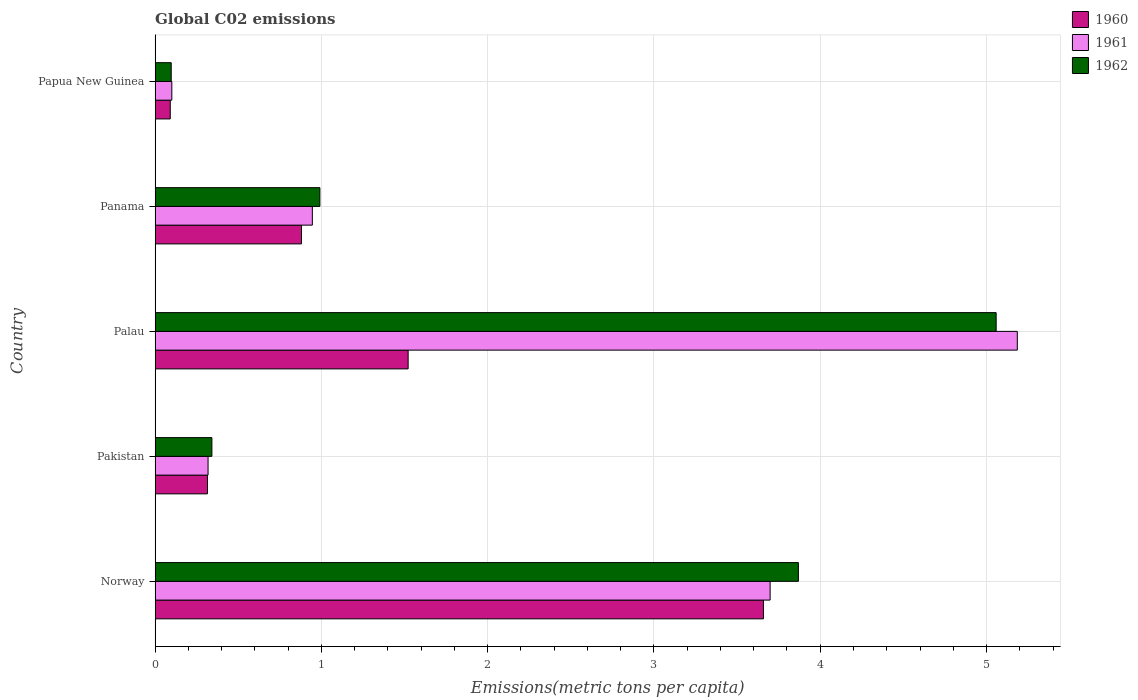How many different coloured bars are there?
Your answer should be compact. 3. Are the number of bars per tick equal to the number of legend labels?
Your response must be concise. Yes. Are the number of bars on each tick of the Y-axis equal?
Your response must be concise. Yes. What is the amount of CO2 emitted in in 1962 in Pakistan?
Offer a very short reply. 0.34. Across all countries, what is the maximum amount of CO2 emitted in in 1960?
Provide a short and direct response. 3.66. Across all countries, what is the minimum amount of CO2 emitted in in 1961?
Your answer should be very brief. 0.1. In which country was the amount of CO2 emitted in in 1960 maximum?
Provide a succinct answer. Norway. In which country was the amount of CO2 emitted in in 1961 minimum?
Offer a very short reply. Papua New Guinea. What is the total amount of CO2 emitted in in 1961 in the graph?
Your answer should be very brief. 10.25. What is the difference between the amount of CO2 emitted in in 1960 in Norway and that in Papua New Guinea?
Offer a terse response. 3.57. What is the difference between the amount of CO2 emitted in in 1962 in Panama and the amount of CO2 emitted in in 1960 in Papua New Guinea?
Your answer should be compact. 0.9. What is the average amount of CO2 emitted in in 1962 per country?
Keep it short and to the point. 2.07. What is the difference between the amount of CO2 emitted in in 1960 and amount of CO2 emitted in in 1962 in Norway?
Keep it short and to the point. -0.21. What is the ratio of the amount of CO2 emitted in in 1961 in Norway to that in Papua New Guinea?
Offer a very short reply. 36.7. Is the difference between the amount of CO2 emitted in in 1960 in Norway and Panama greater than the difference between the amount of CO2 emitted in in 1962 in Norway and Panama?
Make the answer very short. No. What is the difference between the highest and the second highest amount of CO2 emitted in in 1961?
Make the answer very short. 1.49. What is the difference between the highest and the lowest amount of CO2 emitted in in 1961?
Your answer should be compact. 5.08. What does the 1st bar from the top in Pakistan represents?
Provide a short and direct response. 1962. What does the 1st bar from the bottom in Norway represents?
Your answer should be very brief. 1960. What is the difference between two consecutive major ticks on the X-axis?
Provide a short and direct response. 1. Are the values on the major ticks of X-axis written in scientific E-notation?
Provide a short and direct response. No. Does the graph contain grids?
Provide a succinct answer. Yes. Where does the legend appear in the graph?
Your answer should be compact. Top right. How many legend labels are there?
Offer a very short reply. 3. What is the title of the graph?
Give a very brief answer. Global C02 emissions. What is the label or title of the X-axis?
Make the answer very short. Emissions(metric tons per capita). What is the Emissions(metric tons per capita) of 1960 in Norway?
Provide a succinct answer. 3.66. What is the Emissions(metric tons per capita) of 1961 in Norway?
Provide a short and direct response. 3.7. What is the Emissions(metric tons per capita) of 1962 in Norway?
Offer a terse response. 3.87. What is the Emissions(metric tons per capita) of 1960 in Pakistan?
Your response must be concise. 0.32. What is the Emissions(metric tons per capita) of 1961 in Pakistan?
Keep it short and to the point. 0.32. What is the Emissions(metric tons per capita) of 1962 in Pakistan?
Offer a terse response. 0.34. What is the Emissions(metric tons per capita) in 1960 in Palau?
Give a very brief answer. 1.52. What is the Emissions(metric tons per capita) of 1961 in Palau?
Your answer should be compact. 5.19. What is the Emissions(metric tons per capita) in 1962 in Palau?
Your answer should be very brief. 5.06. What is the Emissions(metric tons per capita) in 1960 in Panama?
Provide a succinct answer. 0.88. What is the Emissions(metric tons per capita) in 1961 in Panama?
Make the answer very short. 0.95. What is the Emissions(metric tons per capita) of 1962 in Panama?
Make the answer very short. 0.99. What is the Emissions(metric tons per capita) in 1960 in Papua New Guinea?
Make the answer very short. 0.09. What is the Emissions(metric tons per capita) of 1961 in Papua New Guinea?
Keep it short and to the point. 0.1. What is the Emissions(metric tons per capita) of 1962 in Papua New Guinea?
Keep it short and to the point. 0.1. Across all countries, what is the maximum Emissions(metric tons per capita) of 1960?
Offer a terse response. 3.66. Across all countries, what is the maximum Emissions(metric tons per capita) of 1961?
Your answer should be compact. 5.19. Across all countries, what is the maximum Emissions(metric tons per capita) of 1962?
Provide a short and direct response. 5.06. Across all countries, what is the minimum Emissions(metric tons per capita) of 1960?
Your answer should be compact. 0.09. Across all countries, what is the minimum Emissions(metric tons per capita) in 1961?
Your answer should be very brief. 0.1. Across all countries, what is the minimum Emissions(metric tons per capita) in 1962?
Offer a very short reply. 0.1. What is the total Emissions(metric tons per capita) of 1960 in the graph?
Give a very brief answer. 6.47. What is the total Emissions(metric tons per capita) in 1961 in the graph?
Offer a terse response. 10.25. What is the total Emissions(metric tons per capita) in 1962 in the graph?
Provide a succinct answer. 10.36. What is the difference between the Emissions(metric tons per capita) of 1960 in Norway and that in Pakistan?
Make the answer very short. 3.34. What is the difference between the Emissions(metric tons per capita) of 1961 in Norway and that in Pakistan?
Your response must be concise. 3.38. What is the difference between the Emissions(metric tons per capita) in 1962 in Norway and that in Pakistan?
Give a very brief answer. 3.53. What is the difference between the Emissions(metric tons per capita) of 1960 in Norway and that in Palau?
Offer a very short reply. 2.14. What is the difference between the Emissions(metric tons per capita) of 1961 in Norway and that in Palau?
Ensure brevity in your answer.  -1.49. What is the difference between the Emissions(metric tons per capita) in 1962 in Norway and that in Palau?
Provide a short and direct response. -1.19. What is the difference between the Emissions(metric tons per capita) in 1960 in Norway and that in Panama?
Your response must be concise. 2.78. What is the difference between the Emissions(metric tons per capita) in 1961 in Norway and that in Panama?
Ensure brevity in your answer.  2.75. What is the difference between the Emissions(metric tons per capita) in 1962 in Norway and that in Panama?
Your response must be concise. 2.88. What is the difference between the Emissions(metric tons per capita) of 1960 in Norway and that in Papua New Guinea?
Offer a terse response. 3.57. What is the difference between the Emissions(metric tons per capita) in 1961 in Norway and that in Papua New Guinea?
Provide a short and direct response. 3.6. What is the difference between the Emissions(metric tons per capita) in 1962 in Norway and that in Papua New Guinea?
Your answer should be compact. 3.77. What is the difference between the Emissions(metric tons per capita) of 1960 in Pakistan and that in Palau?
Offer a terse response. -1.21. What is the difference between the Emissions(metric tons per capita) of 1961 in Pakistan and that in Palau?
Your answer should be very brief. -4.87. What is the difference between the Emissions(metric tons per capita) in 1962 in Pakistan and that in Palau?
Provide a succinct answer. -4.72. What is the difference between the Emissions(metric tons per capita) in 1960 in Pakistan and that in Panama?
Ensure brevity in your answer.  -0.57. What is the difference between the Emissions(metric tons per capita) of 1961 in Pakistan and that in Panama?
Give a very brief answer. -0.63. What is the difference between the Emissions(metric tons per capita) in 1962 in Pakistan and that in Panama?
Ensure brevity in your answer.  -0.65. What is the difference between the Emissions(metric tons per capita) of 1960 in Pakistan and that in Papua New Guinea?
Your answer should be very brief. 0.22. What is the difference between the Emissions(metric tons per capita) of 1961 in Pakistan and that in Papua New Guinea?
Give a very brief answer. 0.22. What is the difference between the Emissions(metric tons per capita) of 1962 in Pakistan and that in Papua New Guinea?
Your response must be concise. 0.24. What is the difference between the Emissions(metric tons per capita) in 1960 in Palau and that in Panama?
Make the answer very short. 0.64. What is the difference between the Emissions(metric tons per capita) of 1961 in Palau and that in Panama?
Your answer should be very brief. 4.24. What is the difference between the Emissions(metric tons per capita) in 1962 in Palau and that in Panama?
Offer a very short reply. 4.07. What is the difference between the Emissions(metric tons per capita) of 1960 in Palau and that in Papua New Guinea?
Provide a short and direct response. 1.43. What is the difference between the Emissions(metric tons per capita) in 1961 in Palau and that in Papua New Guinea?
Your answer should be very brief. 5.08. What is the difference between the Emissions(metric tons per capita) in 1962 in Palau and that in Papua New Guinea?
Your answer should be compact. 4.96. What is the difference between the Emissions(metric tons per capita) in 1960 in Panama and that in Papua New Guinea?
Your answer should be very brief. 0.79. What is the difference between the Emissions(metric tons per capita) in 1961 in Panama and that in Papua New Guinea?
Make the answer very short. 0.84. What is the difference between the Emissions(metric tons per capita) of 1962 in Panama and that in Papua New Guinea?
Keep it short and to the point. 0.89. What is the difference between the Emissions(metric tons per capita) of 1960 in Norway and the Emissions(metric tons per capita) of 1961 in Pakistan?
Your answer should be compact. 3.34. What is the difference between the Emissions(metric tons per capita) in 1960 in Norway and the Emissions(metric tons per capita) in 1962 in Pakistan?
Make the answer very short. 3.32. What is the difference between the Emissions(metric tons per capita) of 1961 in Norway and the Emissions(metric tons per capita) of 1962 in Pakistan?
Offer a very short reply. 3.36. What is the difference between the Emissions(metric tons per capita) of 1960 in Norway and the Emissions(metric tons per capita) of 1961 in Palau?
Make the answer very short. -1.53. What is the difference between the Emissions(metric tons per capita) in 1960 in Norway and the Emissions(metric tons per capita) in 1962 in Palau?
Your answer should be compact. -1.4. What is the difference between the Emissions(metric tons per capita) of 1961 in Norway and the Emissions(metric tons per capita) of 1962 in Palau?
Provide a short and direct response. -1.36. What is the difference between the Emissions(metric tons per capita) of 1960 in Norway and the Emissions(metric tons per capita) of 1961 in Panama?
Provide a short and direct response. 2.71. What is the difference between the Emissions(metric tons per capita) of 1960 in Norway and the Emissions(metric tons per capita) of 1962 in Panama?
Offer a terse response. 2.67. What is the difference between the Emissions(metric tons per capita) of 1961 in Norway and the Emissions(metric tons per capita) of 1962 in Panama?
Give a very brief answer. 2.71. What is the difference between the Emissions(metric tons per capita) in 1960 in Norway and the Emissions(metric tons per capita) in 1961 in Papua New Guinea?
Ensure brevity in your answer.  3.56. What is the difference between the Emissions(metric tons per capita) in 1960 in Norway and the Emissions(metric tons per capita) in 1962 in Papua New Guinea?
Your answer should be very brief. 3.56. What is the difference between the Emissions(metric tons per capita) of 1961 in Norway and the Emissions(metric tons per capita) of 1962 in Papua New Guinea?
Ensure brevity in your answer.  3.6. What is the difference between the Emissions(metric tons per capita) in 1960 in Pakistan and the Emissions(metric tons per capita) in 1961 in Palau?
Ensure brevity in your answer.  -4.87. What is the difference between the Emissions(metric tons per capita) of 1960 in Pakistan and the Emissions(metric tons per capita) of 1962 in Palau?
Your answer should be compact. -4.74. What is the difference between the Emissions(metric tons per capita) in 1961 in Pakistan and the Emissions(metric tons per capita) in 1962 in Palau?
Provide a short and direct response. -4.74. What is the difference between the Emissions(metric tons per capita) of 1960 in Pakistan and the Emissions(metric tons per capita) of 1961 in Panama?
Your answer should be compact. -0.63. What is the difference between the Emissions(metric tons per capita) of 1960 in Pakistan and the Emissions(metric tons per capita) of 1962 in Panama?
Your answer should be compact. -0.68. What is the difference between the Emissions(metric tons per capita) in 1961 in Pakistan and the Emissions(metric tons per capita) in 1962 in Panama?
Offer a terse response. -0.67. What is the difference between the Emissions(metric tons per capita) in 1960 in Pakistan and the Emissions(metric tons per capita) in 1961 in Papua New Guinea?
Your answer should be very brief. 0.21. What is the difference between the Emissions(metric tons per capita) in 1960 in Pakistan and the Emissions(metric tons per capita) in 1962 in Papua New Guinea?
Provide a short and direct response. 0.22. What is the difference between the Emissions(metric tons per capita) in 1961 in Pakistan and the Emissions(metric tons per capita) in 1962 in Papua New Guinea?
Ensure brevity in your answer.  0.22. What is the difference between the Emissions(metric tons per capita) of 1960 in Palau and the Emissions(metric tons per capita) of 1961 in Panama?
Your answer should be compact. 0.58. What is the difference between the Emissions(metric tons per capita) in 1960 in Palau and the Emissions(metric tons per capita) in 1962 in Panama?
Your answer should be compact. 0.53. What is the difference between the Emissions(metric tons per capita) in 1961 in Palau and the Emissions(metric tons per capita) in 1962 in Panama?
Provide a succinct answer. 4.19. What is the difference between the Emissions(metric tons per capita) of 1960 in Palau and the Emissions(metric tons per capita) of 1961 in Papua New Guinea?
Keep it short and to the point. 1.42. What is the difference between the Emissions(metric tons per capita) in 1960 in Palau and the Emissions(metric tons per capita) in 1962 in Papua New Guinea?
Give a very brief answer. 1.42. What is the difference between the Emissions(metric tons per capita) in 1961 in Palau and the Emissions(metric tons per capita) in 1962 in Papua New Guinea?
Keep it short and to the point. 5.09. What is the difference between the Emissions(metric tons per capita) in 1960 in Panama and the Emissions(metric tons per capita) in 1961 in Papua New Guinea?
Make the answer very short. 0.78. What is the difference between the Emissions(metric tons per capita) in 1960 in Panama and the Emissions(metric tons per capita) in 1962 in Papua New Guinea?
Ensure brevity in your answer.  0.78. What is the difference between the Emissions(metric tons per capita) of 1961 in Panama and the Emissions(metric tons per capita) of 1962 in Papua New Guinea?
Provide a succinct answer. 0.85. What is the average Emissions(metric tons per capita) in 1960 per country?
Your answer should be compact. 1.29. What is the average Emissions(metric tons per capita) of 1961 per country?
Make the answer very short. 2.05. What is the average Emissions(metric tons per capita) of 1962 per country?
Your response must be concise. 2.07. What is the difference between the Emissions(metric tons per capita) in 1960 and Emissions(metric tons per capita) in 1961 in Norway?
Offer a very short reply. -0.04. What is the difference between the Emissions(metric tons per capita) in 1960 and Emissions(metric tons per capita) in 1962 in Norway?
Provide a succinct answer. -0.21. What is the difference between the Emissions(metric tons per capita) of 1961 and Emissions(metric tons per capita) of 1962 in Norway?
Your answer should be compact. -0.17. What is the difference between the Emissions(metric tons per capita) in 1960 and Emissions(metric tons per capita) in 1961 in Pakistan?
Offer a terse response. -0. What is the difference between the Emissions(metric tons per capita) in 1960 and Emissions(metric tons per capita) in 1962 in Pakistan?
Provide a short and direct response. -0.03. What is the difference between the Emissions(metric tons per capita) of 1961 and Emissions(metric tons per capita) of 1962 in Pakistan?
Make the answer very short. -0.02. What is the difference between the Emissions(metric tons per capita) in 1960 and Emissions(metric tons per capita) in 1961 in Palau?
Provide a short and direct response. -3.66. What is the difference between the Emissions(metric tons per capita) of 1960 and Emissions(metric tons per capita) of 1962 in Palau?
Your answer should be compact. -3.54. What is the difference between the Emissions(metric tons per capita) of 1961 and Emissions(metric tons per capita) of 1962 in Palau?
Provide a short and direct response. 0.13. What is the difference between the Emissions(metric tons per capita) in 1960 and Emissions(metric tons per capita) in 1961 in Panama?
Offer a very short reply. -0.07. What is the difference between the Emissions(metric tons per capita) in 1960 and Emissions(metric tons per capita) in 1962 in Panama?
Give a very brief answer. -0.11. What is the difference between the Emissions(metric tons per capita) in 1961 and Emissions(metric tons per capita) in 1962 in Panama?
Give a very brief answer. -0.05. What is the difference between the Emissions(metric tons per capita) of 1960 and Emissions(metric tons per capita) of 1961 in Papua New Guinea?
Ensure brevity in your answer.  -0.01. What is the difference between the Emissions(metric tons per capita) in 1960 and Emissions(metric tons per capita) in 1962 in Papua New Guinea?
Your answer should be very brief. -0.01. What is the difference between the Emissions(metric tons per capita) in 1961 and Emissions(metric tons per capita) in 1962 in Papua New Guinea?
Keep it short and to the point. 0. What is the ratio of the Emissions(metric tons per capita) of 1960 in Norway to that in Pakistan?
Keep it short and to the point. 11.61. What is the ratio of the Emissions(metric tons per capita) in 1961 in Norway to that in Pakistan?
Ensure brevity in your answer.  11.61. What is the ratio of the Emissions(metric tons per capita) in 1962 in Norway to that in Pakistan?
Make the answer very short. 11.32. What is the ratio of the Emissions(metric tons per capita) in 1960 in Norway to that in Palau?
Keep it short and to the point. 2.4. What is the ratio of the Emissions(metric tons per capita) in 1961 in Norway to that in Palau?
Your response must be concise. 0.71. What is the ratio of the Emissions(metric tons per capita) of 1962 in Norway to that in Palau?
Offer a terse response. 0.76. What is the ratio of the Emissions(metric tons per capita) in 1960 in Norway to that in Panama?
Your response must be concise. 4.16. What is the ratio of the Emissions(metric tons per capita) of 1961 in Norway to that in Panama?
Ensure brevity in your answer.  3.91. What is the ratio of the Emissions(metric tons per capita) in 1962 in Norway to that in Panama?
Make the answer very short. 3.9. What is the ratio of the Emissions(metric tons per capita) of 1960 in Norway to that in Papua New Guinea?
Provide a short and direct response. 40.05. What is the ratio of the Emissions(metric tons per capita) in 1961 in Norway to that in Papua New Guinea?
Provide a short and direct response. 36.7. What is the ratio of the Emissions(metric tons per capita) in 1962 in Norway to that in Papua New Guinea?
Offer a terse response. 39.8. What is the ratio of the Emissions(metric tons per capita) of 1960 in Pakistan to that in Palau?
Give a very brief answer. 0.21. What is the ratio of the Emissions(metric tons per capita) of 1961 in Pakistan to that in Palau?
Provide a short and direct response. 0.06. What is the ratio of the Emissions(metric tons per capita) of 1962 in Pakistan to that in Palau?
Make the answer very short. 0.07. What is the ratio of the Emissions(metric tons per capita) in 1960 in Pakistan to that in Panama?
Provide a short and direct response. 0.36. What is the ratio of the Emissions(metric tons per capita) in 1961 in Pakistan to that in Panama?
Offer a terse response. 0.34. What is the ratio of the Emissions(metric tons per capita) of 1962 in Pakistan to that in Panama?
Make the answer very short. 0.34. What is the ratio of the Emissions(metric tons per capita) in 1960 in Pakistan to that in Papua New Guinea?
Provide a short and direct response. 3.45. What is the ratio of the Emissions(metric tons per capita) of 1961 in Pakistan to that in Papua New Guinea?
Keep it short and to the point. 3.16. What is the ratio of the Emissions(metric tons per capita) of 1962 in Pakistan to that in Papua New Guinea?
Offer a terse response. 3.52. What is the ratio of the Emissions(metric tons per capita) of 1960 in Palau to that in Panama?
Offer a very short reply. 1.73. What is the ratio of the Emissions(metric tons per capita) of 1961 in Palau to that in Panama?
Offer a terse response. 5.48. What is the ratio of the Emissions(metric tons per capita) in 1962 in Palau to that in Panama?
Offer a very short reply. 5.1. What is the ratio of the Emissions(metric tons per capita) in 1960 in Palau to that in Papua New Guinea?
Make the answer very short. 16.66. What is the ratio of the Emissions(metric tons per capita) of 1961 in Palau to that in Papua New Guinea?
Provide a short and direct response. 51.45. What is the ratio of the Emissions(metric tons per capita) in 1962 in Palau to that in Papua New Guinea?
Keep it short and to the point. 52.03. What is the ratio of the Emissions(metric tons per capita) in 1960 in Panama to that in Papua New Guinea?
Offer a terse response. 9.64. What is the ratio of the Emissions(metric tons per capita) of 1961 in Panama to that in Papua New Guinea?
Your answer should be compact. 9.38. What is the ratio of the Emissions(metric tons per capita) of 1962 in Panama to that in Papua New Guinea?
Your answer should be compact. 10.2. What is the difference between the highest and the second highest Emissions(metric tons per capita) in 1960?
Your answer should be very brief. 2.14. What is the difference between the highest and the second highest Emissions(metric tons per capita) in 1961?
Keep it short and to the point. 1.49. What is the difference between the highest and the second highest Emissions(metric tons per capita) in 1962?
Your response must be concise. 1.19. What is the difference between the highest and the lowest Emissions(metric tons per capita) of 1960?
Your response must be concise. 3.57. What is the difference between the highest and the lowest Emissions(metric tons per capita) in 1961?
Provide a succinct answer. 5.08. What is the difference between the highest and the lowest Emissions(metric tons per capita) of 1962?
Give a very brief answer. 4.96. 